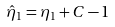Convert formula to latex. <formula><loc_0><loc_0><loc_500><loc_500>\hat { \eta } _ { 1 } = \eta _ { 1 } + C - 1</formula> 